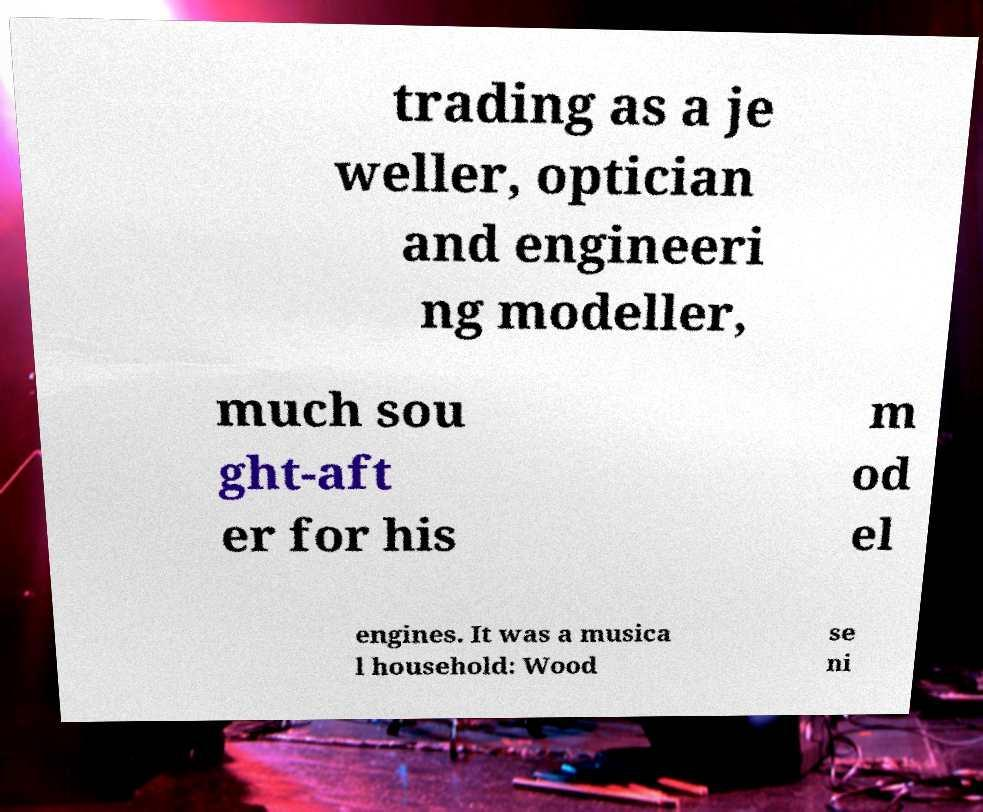I need the written content from this picture converted into text. Can you do that? trading as a je weller, optician and engineeri ng modeller, much sou ght-aft er for his m od el engines. It was a musica l household: Wood se ni 